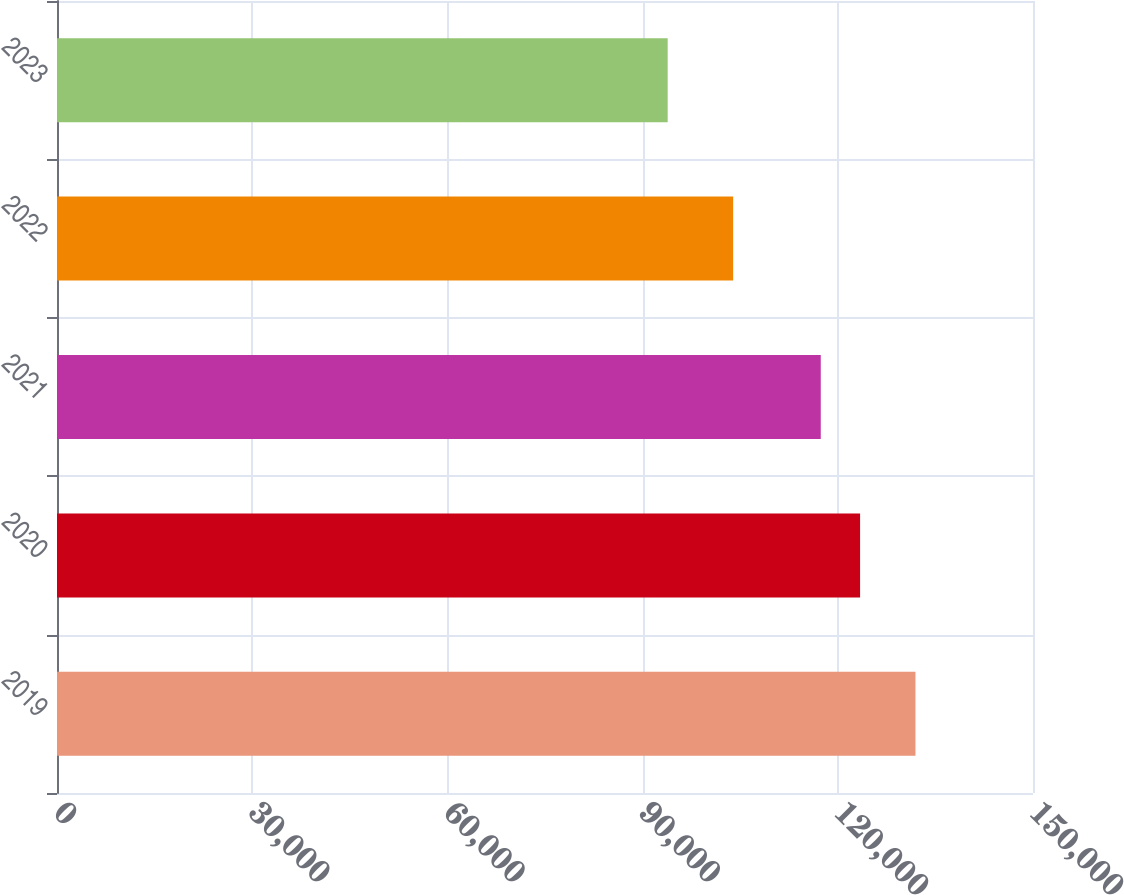<chart> <loc_0><loc_0><loc_500><loc_500><bar_chart><fcel>2019<fcel>2020<fcel>2021<fcel>2022<fcel>2023<nl><fcel>131936<fcel>123425<fcel>117381<fcel>103917<fcel>93854<nl></chart> 